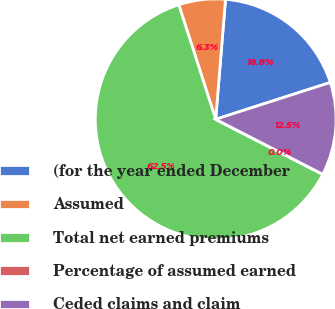Convert chart. <chart><loc_0><loc_0><loc_500><loc_500><pie_chart><fcel>(for the year ended December<fcel>Assumed<fcel>Total net earned premiums<fcel>Percentage of assumed earned<fcel>Ceded claims and claim<nl><fcel>18.75%<fcel>6.26%<fcel>62.48%<fcel>0.01%<fcel>12.5%<nl></chart> 